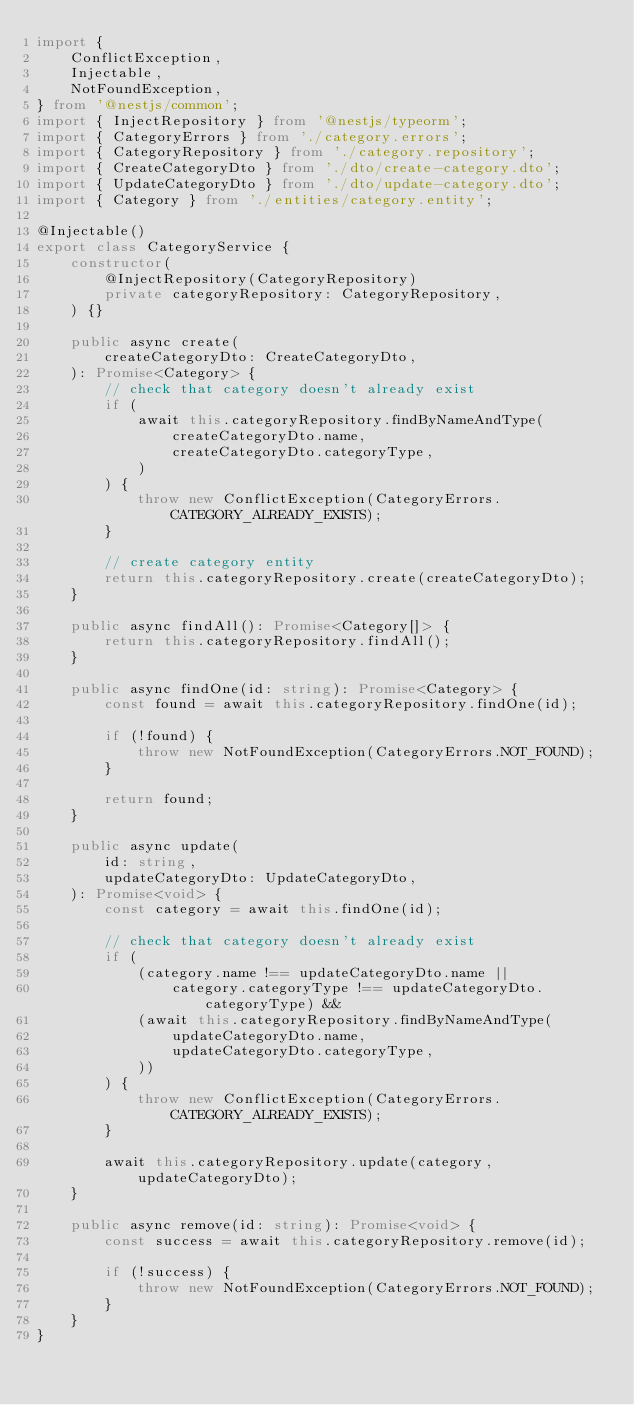<code> <loc_0><loc_0><loc_500><loc_500><_TypeScript_>import {
    ConflictException,
    Injectable,
    NotFoundException,
} from '@nestjs/common';
import { InjectRepository } from '@nestjs/typeorm';
import { CategoryErrors } from './category.errors';
import { CategoryRepository } from './category.repository';
import { CreateCategoryDto } from './dto/create-category.dto';
import { UpdateCategoryDto } from './dto/update-category.dto';
import { Category } from './entities/category.entity';

@Injectable()
export class CategoryService {
    constructor(
        @InjectRepository(CategoryRepository)
        private categoryRepository: CategoryRepository,
    ) {}

    public async create(
        createCategoryDto: CreateCategoryDto,
    ): Promise<Category> {
        // check that category doesn't already exist
        if (
            await this.categoryRepository.findByNameAndType(
                createCategoryDto.name,
                createCategoryDto.categoryType,
            )
        ) {
            throw new ConflictException(CategoryErrors.CATEGORY_ALREADY_EXISTS);
        }

        // create category entity
        return this.categoryRepository.create(createCategoryDto);
    }

    public async findAll(): Promise<Category[]> {
        return this.categoryRepository.findAll();
    }

    public async findOne(id: string): Promise<Category> {
        const found = await this.categoryRepository.findOne(id);

        if (!found) {
            throw new NotFoundException(CategoryErrors.NOT_FOUND);
        }

        return found;
    }

    public async update(
        id: string,
        updateCategoryDto: UpdateCategoryDto,
    ): Promise<void> {
        const category = await this.findOne(id);

        // check that category doesn't already exist
        if (
            (category.name !== updateCategoryDto.name ||
                category.categoryType !== updateCategoryDto.categoryType) &&
            (await this.categoryRepository.findByNameAndType(
                updateCategoryDto.name,
                updateCategoryDto.categoryType,
            ))
        ) {
            throw new ConflictException(CategoryErrors.CATEGORY_ALREADY_EXISTS);
        }

        await this.categoryRepository.update(category, updateCategoryDto);
    }

    public async remove(id: string): Promise<void> {
        const success = await this.categoryRepository.remove(id);

        if (!success) {
            throw new NotFoundException(CategoryErrors.NOT_FOUND);
        }
    }
}
</code> 